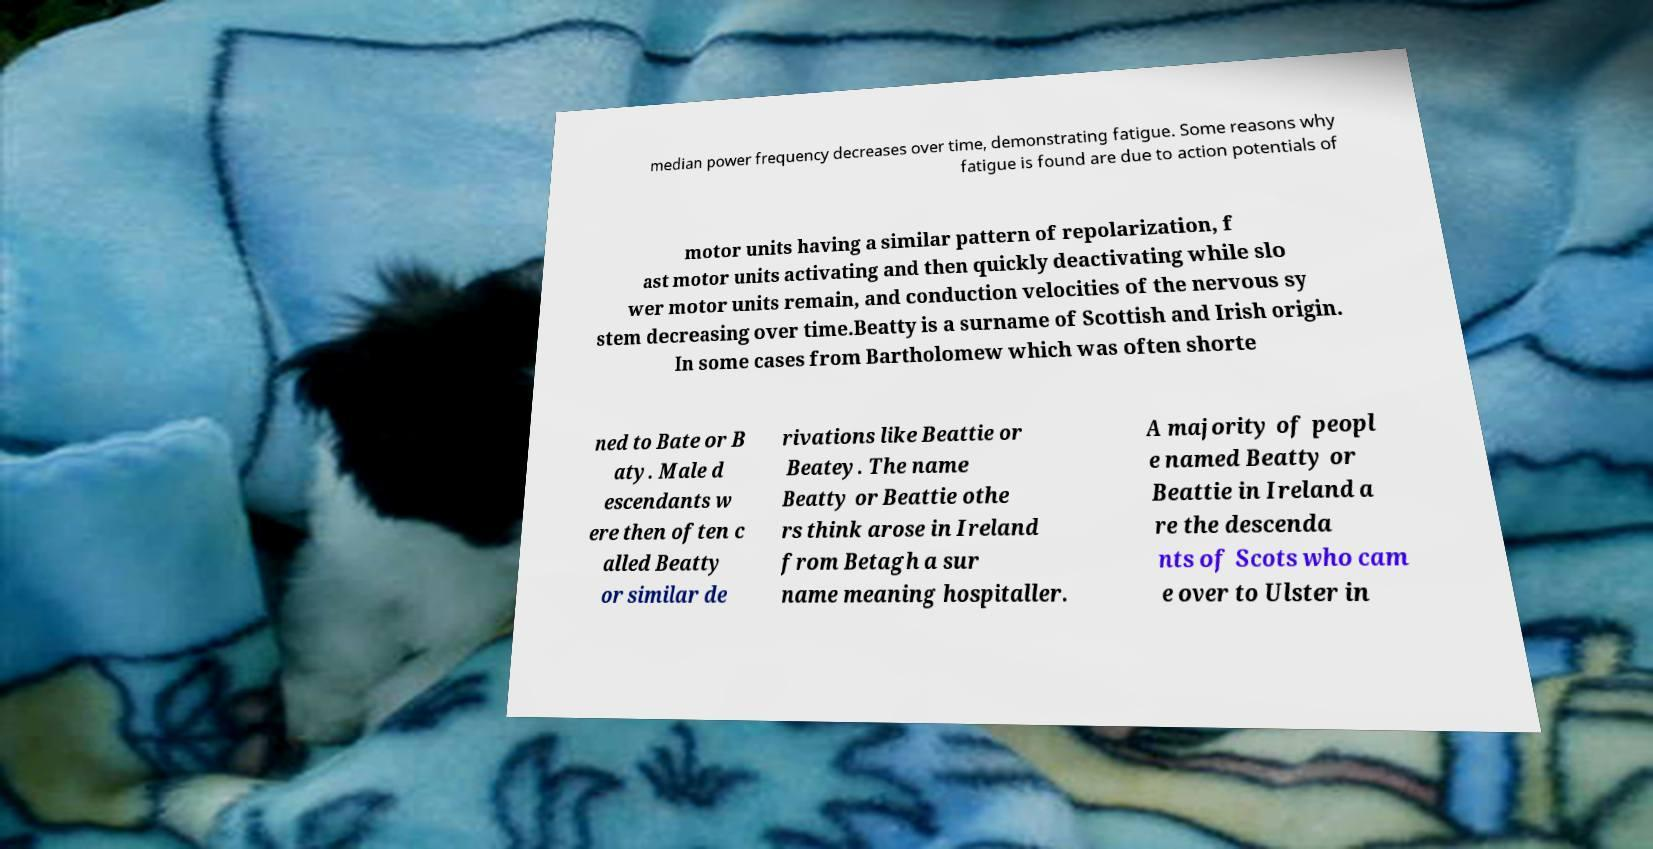What messages or text are displayed in this image? I need them in a readable, typed format. median power frequency decreases over time, demonstrating fatigue. Some reasons why fatigue is found are due to action potentials of motor units having a similar pattern of repolarization, f ast motor units activating and then quickly deactivating while slo wer motor units remain, and conduction velocities of the nervous sy stem decreasing over time.Beatty is a surname of Scottish and Irish origin. In some cases from Bartholomew which was often shorte ned to Bate or B aty. Male d escendants w ere then often c alled Beatty or similar de rivations like Beattie or Beatey. The name Beatty or Beattie othe rs think arose in Ireland from Betagh a sur name meaning hospitaller. A majority of peopl e named Beatty or Beattie in Ireland a re the descenda nts of Scots who cam e over to Ulster in 